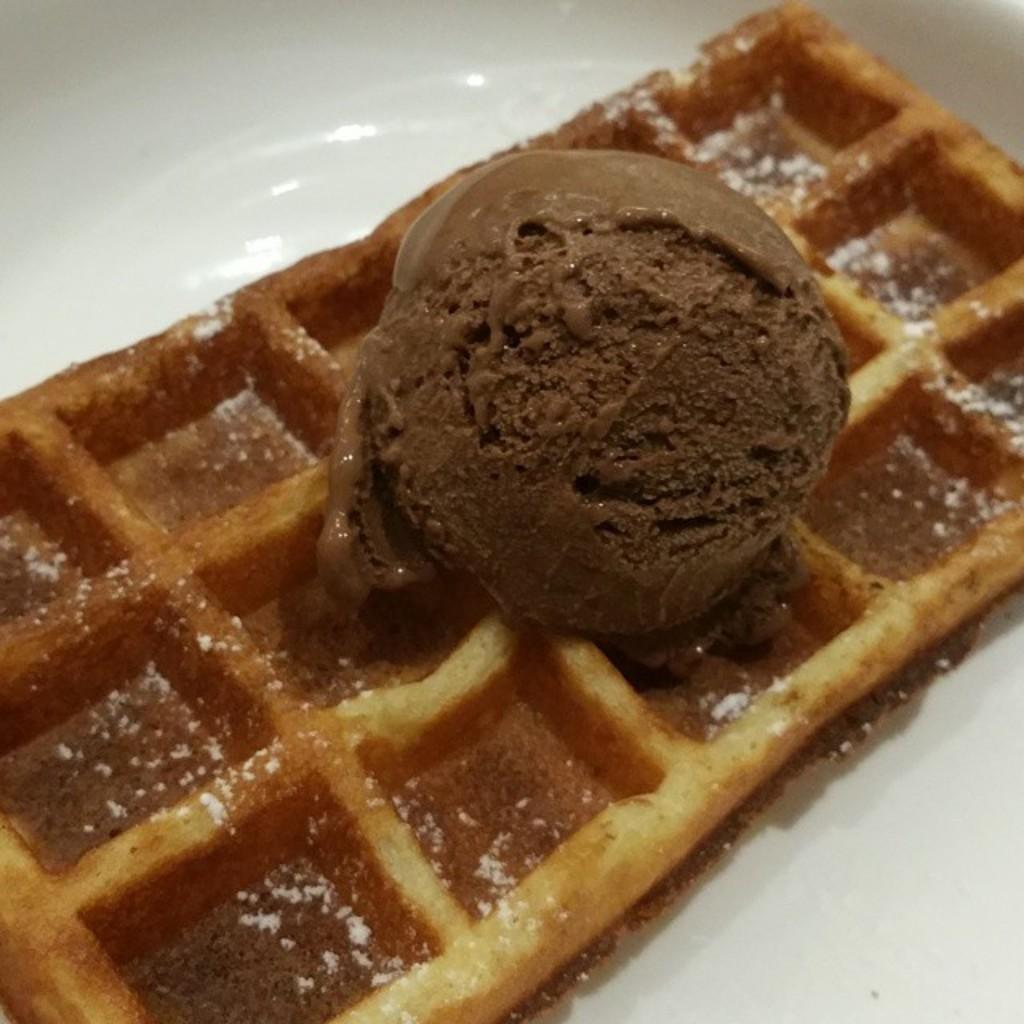What type of dessert is featured in the image? There is an ice cream in the image. What is the color of the ice cream? The ice cream is in brown color. What other item is present in the image? There is a wafer in the image. How are the ice cream and wafer arranged in the image? The ice cream and wafer are on a plate. What is the color of the plate? The plate is in white color. Where is the baby sitting while eating the ice cream in the image? There is no baby present in the image; it only features an ice cream, a wafer, and a plate. 